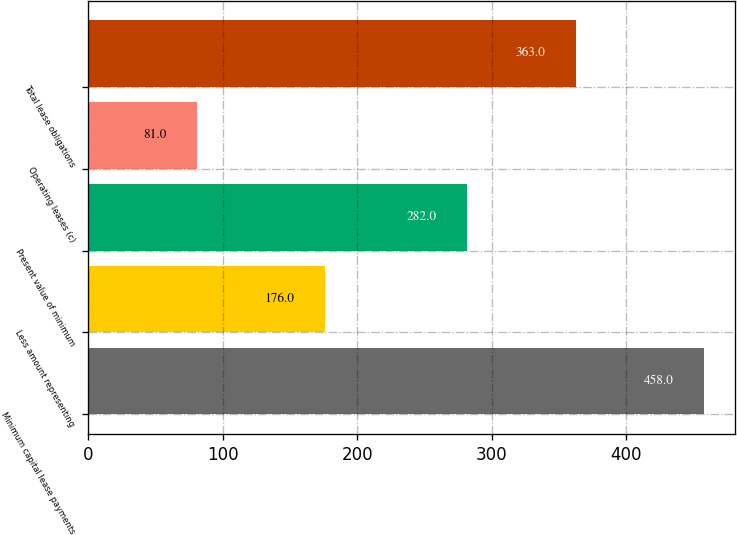Convert chart. <chart><loc_0><loc_0><loc_500><loc_500><bar_chart><fcel>Minimum capital lease payments<fcel>Less amount representing<fcel>Present value of minimum<fcel>Operating leases (c)<fcel>Total lease obligations<nl><fcel>458<fcel>176<fcel>282<fcel>81<fcel>363<nl></chart> 